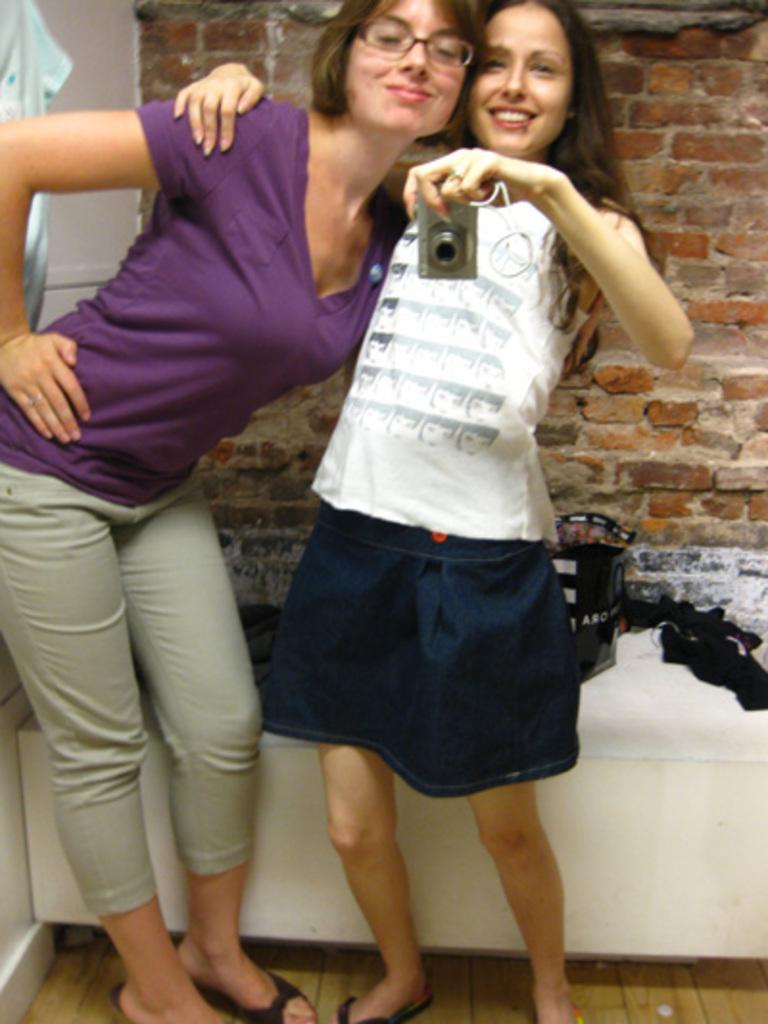How many people are in the image? There are two women in the image. What are the women doing in the image? The women are holding each other. What is one of the women holding? One of the women is holding a camera. What can be seen in the background of the image? There are objects placed on a table and a wall visible in the background. What type of lamp is on the table in the image? There is no lamp present in the image; only objects are placed on the table. Can you tell me how many bags of popcorn are on the table in the image? There is no popcorn present in the image; only objects are placed on the table. 